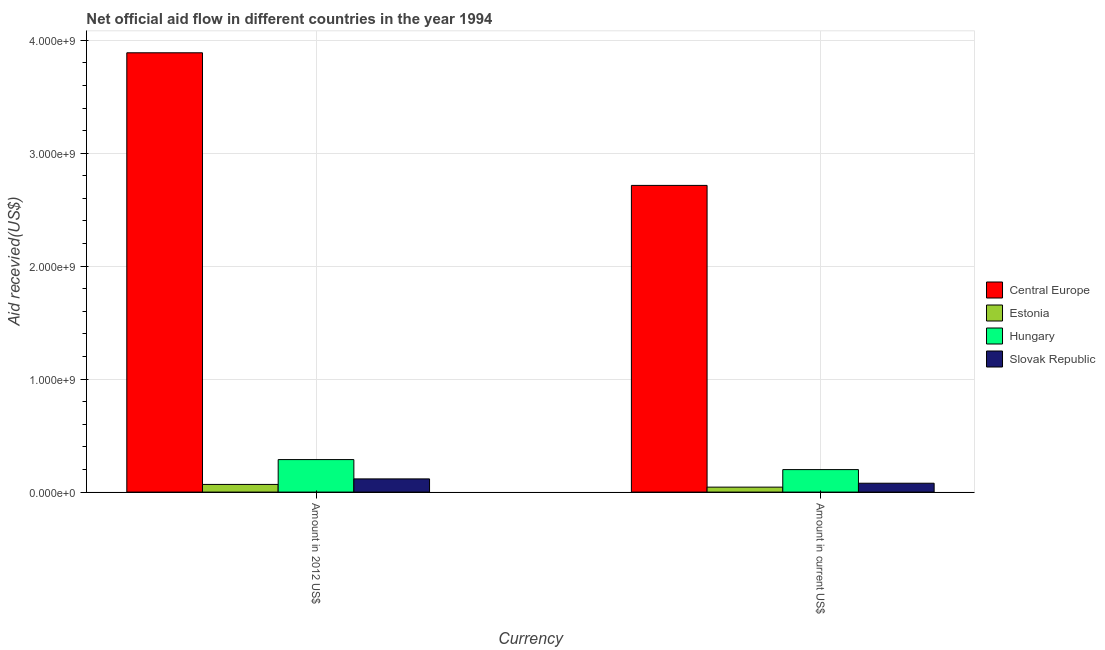How many different coloured bars are there?
Your answer should be very brief. 4. How many groups of bars are there?
Your answer should be very brief. 2. Are the number of bars on each tick of the X-axis equal?
Offer a terse response. Yes. How many bars are there on the 2nd tick from the right?
Your answer should be very brief. 4. What is the label of the 1st group of bars from the left?
Ensure brevity in your answer.  Amount in 2012 US$. What is the amount of aid received(expressed in us$) in Estonia?
Make the answer very short. 4.38e+07. Across all countries, what is the maximum amount of aid received(expressed in 2012 us$)?
Provide a short and direct response. 3.89e+09. Across all countries, what is the minimum amount of aid received(expressed in us$)?
Provide a short and direct response. 4.38e+07. In which country was the amount of aid received(expressed in us$) maximum?
Provide a succinct answer. Central Europe. In which country was the amount of aid received(expressed in 2012 us$) minimum?
Give a very brief answer. Estonia. What is the total amount of aid received(expressed in 2012 us$) in the graph?
Keep it short and to the point. 4.36e+09. What is the difference between the amount of aid received(expressed in 2012 us$) in Estonia and that in Hungary?
Provide a succinct answer. -2.20e+08. What is the difference between the amount of aid received(expressed in us$) in Central Europe and the amount of aid received(expressed in 2012 us$) in Estonia?
Provide a succinct answer. 2.65e+09. What is the average amount of aid received(expressed in 2012 us$) per country?
Your answer should be very brief. 1.09e+09. What is the difference between the amount of aid received(expressed in us$) and amount of aid received(expressed in 2012 us$) in Central Europe?
Your answer should be compact. -1.17e+09. In how many countries, is the amount of aid received(expressed in 2012 us$) greater than 2000000000 US$?
Your response must be concise. 1. What is the ratio of the amount of aid received(expressed in us$) in Estonia to that in Slovak Republic?
Your answer should be compact. 0.56. In how many countries, is the amount of aid received(expressed in us$) greater than the average amount of aid received(expressed in us$) taken over all countries?
Offer a terse response. 1. What does the 4th bar from the left in Amount in 2012 US$ represents?
Provide a short and direct response. Slovak Republic. What does the 1st bar from the right in Amount in 2012 US$ represents?
Your answer should be compact. Slovak Republic. How many countries are there in the graph?
Keep it short and to the point. 4. What is the difference between two consecutive major ticks on the Y-axis?
Offer a very short reply. 1.00e+09. Does the graph contain any zero values?
Ensure brevity in your answer.  No. Does the graph contain grids?
Your answer should be compact. Yes. What is the title of the graph?
Offer a terse response. Net official aid flow in different countries in the year 1994. What is the label or title of the X-axis?
Your response must be concise. Currency. What is the label or title of the Y-axis?
Make the answer very short. Aid recevied(US$). What is the Aid recevied(US$) of Central Europe in Amount in 2012 US$?
Your response must be concise. 3.89e+09. What is the Aid recevied(US$) in Estonia in Amount in 2012 US$?
Make the answer very short. 6.78e+07. What is the Aid recevied(US$) of Hungary in Amount in 2012 US$?
Provide a succinct answer. 2.88e+08. What is the Aid recevied(US$) in Slovak Republic in Amount in 2012 US$?
Ensure brevity in your answer.  1.17e+08. What is the Aid recevied(US$) of Central Europe in Amount in current US$?
Your answer should be compact. 2.71e+09. What is the Aid recevied(US$) in Estonia in Amount in current US$?
Your response must be concise. 4.38e+07. What is the Aid recevied(US$) of Hungary in Amount in current US$?
Give a very brief answer. 1.99e+08. What is the Aid recevied(US$) in Slovak Republic in Amount in current US$?
Your answer should be very brief. 7.84e+07. Across all Currency, what is the maximum Aid recevied(US$) of Central Europe?
Make the answer very short. 3.89e+09. Across all Currency, what is the maximum Aid recevied(US$) in Estonia?
Give a very brief answer. 6.78e+07. Across all Currency, what is the maximum Aid recevied(US$) in Hungary?
Your response must be concise. 2.88e+08. Across all Currency, what is the maximum Aid recevied(US$) of Slovak Republic?
Provide a short and direct response. 1.17e+08. Across all Currency, what is the minimum Aid recevied(US$) in Central Europe?
Offer a very short reply. 2.71e+09. Across all Currency, what is the minimum Aid recevied(US$) in Estonia?
Keep it short and to the point. 4.38e+07. Across all Currency, what is the minimum Aid recevied(US$) in Hungary?
Your answer should be very brief. 1.99e+08. Across all Currency, what is the minimum Aid recevied(US$) of Slovak Republic?
Offer a terse response. 7.84e+07. What is the total Aid recevied(US$) of Central Europe in the graph?
Give a very brief answer. 6.60e+09. What is the total Aid recevied(US$) of Estonia in the graph?
Provide a succinct answer. 1.12e+08. What is the total Aid recevied(US$) in Hungary in the graph?
Offer a very short reply. 4.87e+08. What is the total Aid recevied(US$) of Slovak Republic in the graph?
Offer a terse response. 1.95e+08. What is the difference between the Aid recevied(US$) of Central Europe in Amount in 2012 US$ and that in Amount in current US$?
Keep it short and to the point. 1.17e+09. What is the difference between the Aid recevied(US$) in Estonia in Amount in 2012 US$ and that in Amount in current US$?
Ensure brevity in your answer.  2.40e+07. What is the difference between the Aid recevied(US$) in Hungary in Amount in 2012 US$ and that in Amount in current US$?
Make the answer very short. 8.87e+07. What is the difference between the Aid recevied(US$) in Slovak Republic in Amount in 2012 US$ and that in Amount in current US$?
Your answer should be compact. 3.84e+07. What is the difference between the Aid recevied(US$) of Central Europe in Amount in 2012 US$ and the Aid recevied(US$) of Estonia in Amount in current US$?
Keep it short and to the point. 3.85e+09. What is the difference between the Aid recevied(US$) in Central Europe in Amount in 2012 US$ and the Aid recevied(US$) in Hungary in Amount in current US$?
Make the answer very short. 3.69e+09. What is the difference between the Aid recevied(US$) in Central Europe in Amount in 2012 US$ and the Aid recevied(US$) in Slovak Republic in Amount in current US$?
Provide a short and direct response. 3.81e+09. What is the difference between the Aid recevied(US$) in Estonia in Amount in 2012 US$ and the Aid recevied(US$) in Hungary in Amount in current US$?
Your response must be concise. -1.31e+08. What is the difference between the Aid recevied(US$) of Estonia in Amount in 2012 US$ and the Aid recevied(US$) of Slovak Republic in Amount in current US$?
Provide a short and direct response. -1.06e+07. What is the difference between the Aid recevied(US$) in Hungary in Amount in 2012 US$ and the Aid recevied(US$) in Slovak Republic in Amount in current US$?
Your answer should be compact. 2.09e+08. What is the average Aid recevied(US$) of Central Europe per Currency?
Offer a terse response. 3.30e+09. What is the average Aid recevied(US$) of Estonia per Currency?
Keep it short and to the point. 5.58e+07. What is the average Aid recevied(US$) in Hungary per Currency?
Your answer should be very brief. 2.43e+08. What is the average Aid recevied(US$) in Slovak Republic per Currency?
Offer a very short reply. 9.76e+07. What is the difference between the Aid recevied(US$) of Central Europe and Aid recevied(US$) of Estonia in Amount in 2012 US$?
Give a very brief answer. 3.82e+09. What is the difference between the Aid recevied(US$) in Central Europe and Aid recevied(US$) in Hungary in Amount in 2012 US$?
Provide a short and direct response. 3.60e+09. What is the difference between the Aid recevied(US$) in Central Europe and Aid recevied(US$) in Slovak Republic in Amount in 2012 US$?
Provide a succinct answer. 3.77e+09. What is the difference between the Aid recevied(US$) in Estonia and Aid recevied(US$) in Hungary in Amount in 2012 US$?
Provide a short and direct response. -2.20e+08. What is the difference between the Aid recevied(US$) of Estonia and Aid recevied(US$) of Slovak Republic in Amount in 2012 US$?
Provide a short and direct response. -4.90e+07. What is the difference between the Aid recevied(US$) of Hungary and Aid recevied(US$) of Slovak Republic in Amount in 2012 US$?
Your answer should be very brief. 1.71e+08. What is the difference between the Aid recevied(US$) in Central Europe and Aid recevied(US$) in Estonia in Amount in current US$?
Your answer should be compact. 2.67e+09. What is the difference between the Aid recevied(US$) of Central Europe and Aid recevied(US$) of Hungary in Amount in current US$?
Offer a very short reply. 2.52e+09. What is the difference between the Aid recevied(US$) of Central Europe and Aid recevied(US$) of Slovak Republic in Amount in current US$?
Ensure brevity in your answer.  2.64e+09. What is the difference between the Aid recevied(US$) of Estonia and Aid recevied(US$) of Hungary in Amount in current US$?
Your answer should be very brief. -1.55e+08. What is the difference between the Aid recevied(US$) in Estonia and Aid recevied(US$) in Slovak Republic in Amount in current US$?
Give a very brief answer. -3.46e+07. What is the difference between the Aid recevied(US$) in Hungary and Aid recevied(US$) in Slovak Republic in Amount in current US$?
Your answer should be very brief. 1.21e+08. What is the ratio of the Aid recevied(US$) in Central Europe in Amount in 2012 US$ to that in Amount in current US$?
Your answer should be very brief. 1.43. What is the ratio of the Aid recevied(US$) in Estonia in Amount in 2012 US$ to that in Amount in current US$?
Offer a very short reply. 1.55. What is the ratio of the Aid recevied(US$) of Hungary in Amount in 2012 US$ to that in Amount in current US$?
Your answer should be very brief. 1.45. What is the ratio of the Aid recevied(US$) in Slovak Republic in Amount in 2012 US$ to that in Amount in current US$?
Your answer should be very brief. 1.49. What is the difference between the highest and the second highest Aid recevied(US$) in Central Europe?
Your response must be concise. 1.17e+09. What is the difference between the highest and the second highest Aid recevied(US$) of Estonia?
Provide a short and direct response. 2.40e+07. What is the difference between the highest and the second highest Aid recevied(US$) in Hungary?
Your answer should be compact. 8.87e+07. What is the difference between the highest and the second highest Aid recevied(US$) in Slovak Republic?
Your answer should be compact. 3.84e+07. What is the difference between the highest and the lowest Aid recevied(US$) of Central Europe?
Your answer should be very brief. 1.17e+09. What is the difference between the highest and the lowest Aid recevied(US$) in Estonia?
Offer a very short reply. 2.40e+07. What is the difference between the highest and the lowest Aid recevied(US$) in Hungary?
Offer a very short reply. 8.87e+07. What is the difference between the highest and the lowest Aid recevied(US$) of Slovak Republic?
Provide a succinct answer. 3.84e+07. 